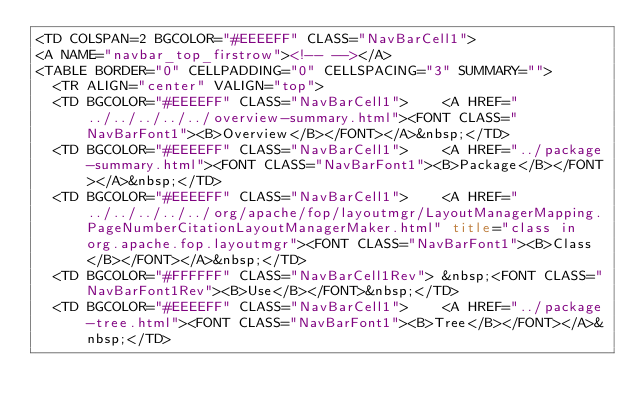Convert code to text. <code><loc_0><loc_0><loc_500><loc_500><_HTML_><TD COLSPAN=2 BGCOLOR="#EEEEFF" CLASS="NavBarCell1">
<A NAME="navbar_top_firstrow"><!-- --></A>
<TABLE BORDER="0" CELLPADDING="0" CELLSPACING="3" SUMMARY="">
  <TR ALIGN="center" VALIGN="top">
  <TD BGCOLOR="#EEEEFF" CLASS="NavBarCell1">    <A HREF="../../../../../overview-summary.html"><FONT CLASS="NavBarFont1"><B>Overview</B></FONT></A>&nbsp;</TD>
  <TD BGCOLOR="#EEEEFF" CLASS="NavBarCell1">    <A HREF="../package-summary.html"><FONT CLASS="NavBarFont1"><B>Package</B></FONT></A>&nbsp;</TD>
  <TD BGCOLOR="#EEEEFF" CLASS="NavBarCell1">    <A HREF="../../../../../org/apache/fop/layoutmgr/LayoutManagerMapping.PageNumberCitationLayoutManagerMaker.html" title="class in org.apache.fop.layoutmgr"><FONT CLASS="NavBarFont1"><B>Class</B></FONT></A>&nbsp;</TD>
  <TD BGCOLOR="#FFFFFF" CLASS="NavBarCell1Rev"> &nbsp;<FONT CLASS="NavBarFont1Rev"><B>Use</B></FONT>&nbsp;</TD>
  <TD BGCOLOR="#EEEEFF" CLASS="NavBarCell1">    <A HREF="../package-tree.html"><FONT CLASS="NavBarFont1"><B>Tree</B></FONT></A>&nbsp;</TD></code> 